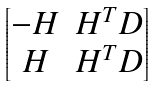Convert formula to latex. <formula><loc_0><loc_0><loc_500><loc_500>\begin{bmatrix} - H & H ^ { T } D \\ H & H ^ { T } D \end{bmatrix}</formula> 